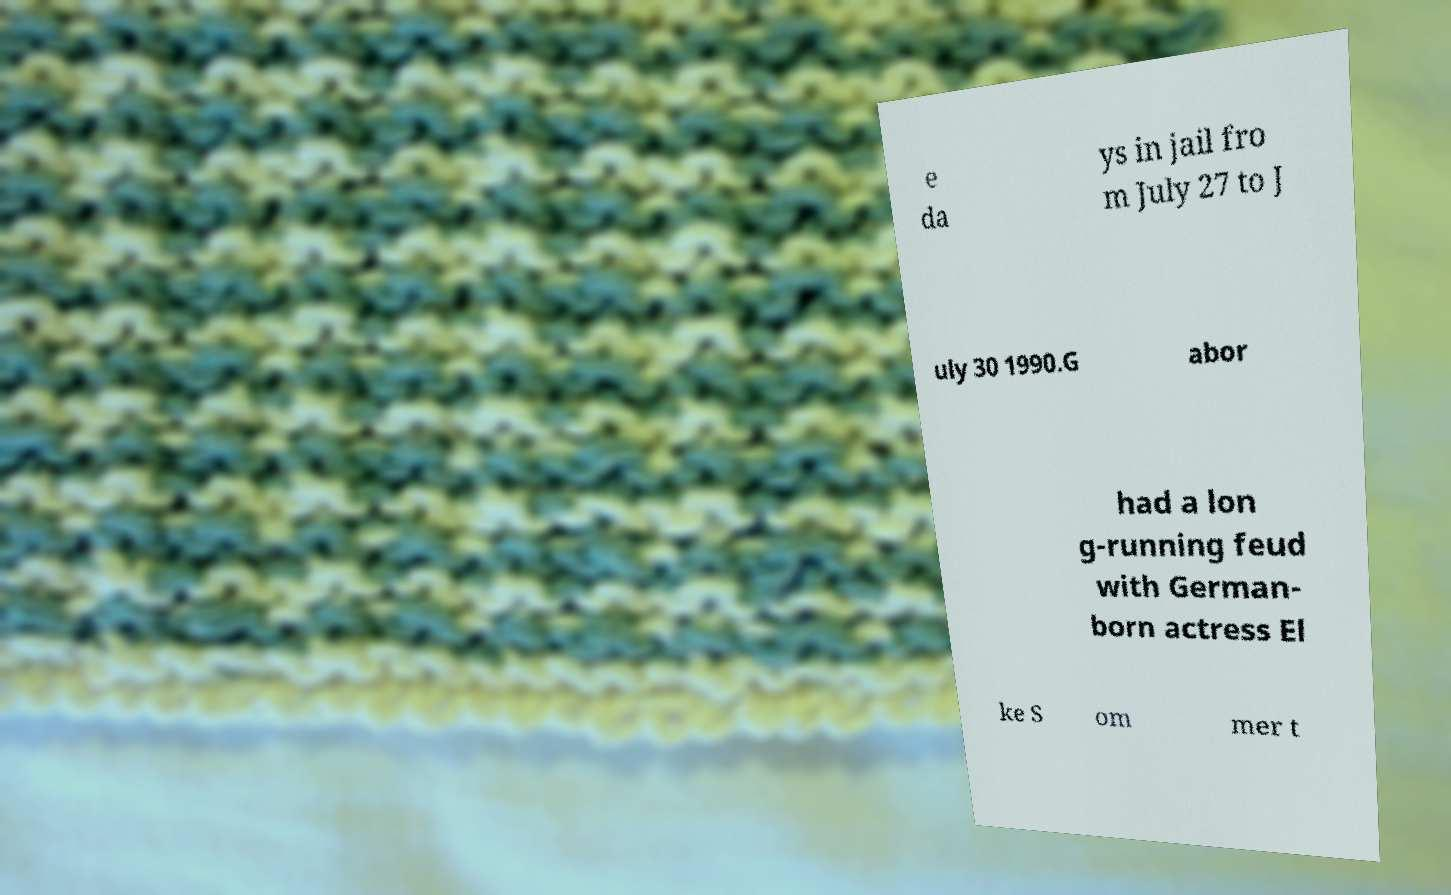Please read and relay the text visible in this image. What does it say? e da ys in jail fro m July 27 to J uly 30 1990.G abor had a lon g-running feud with German- born actress El ke S om mer t 